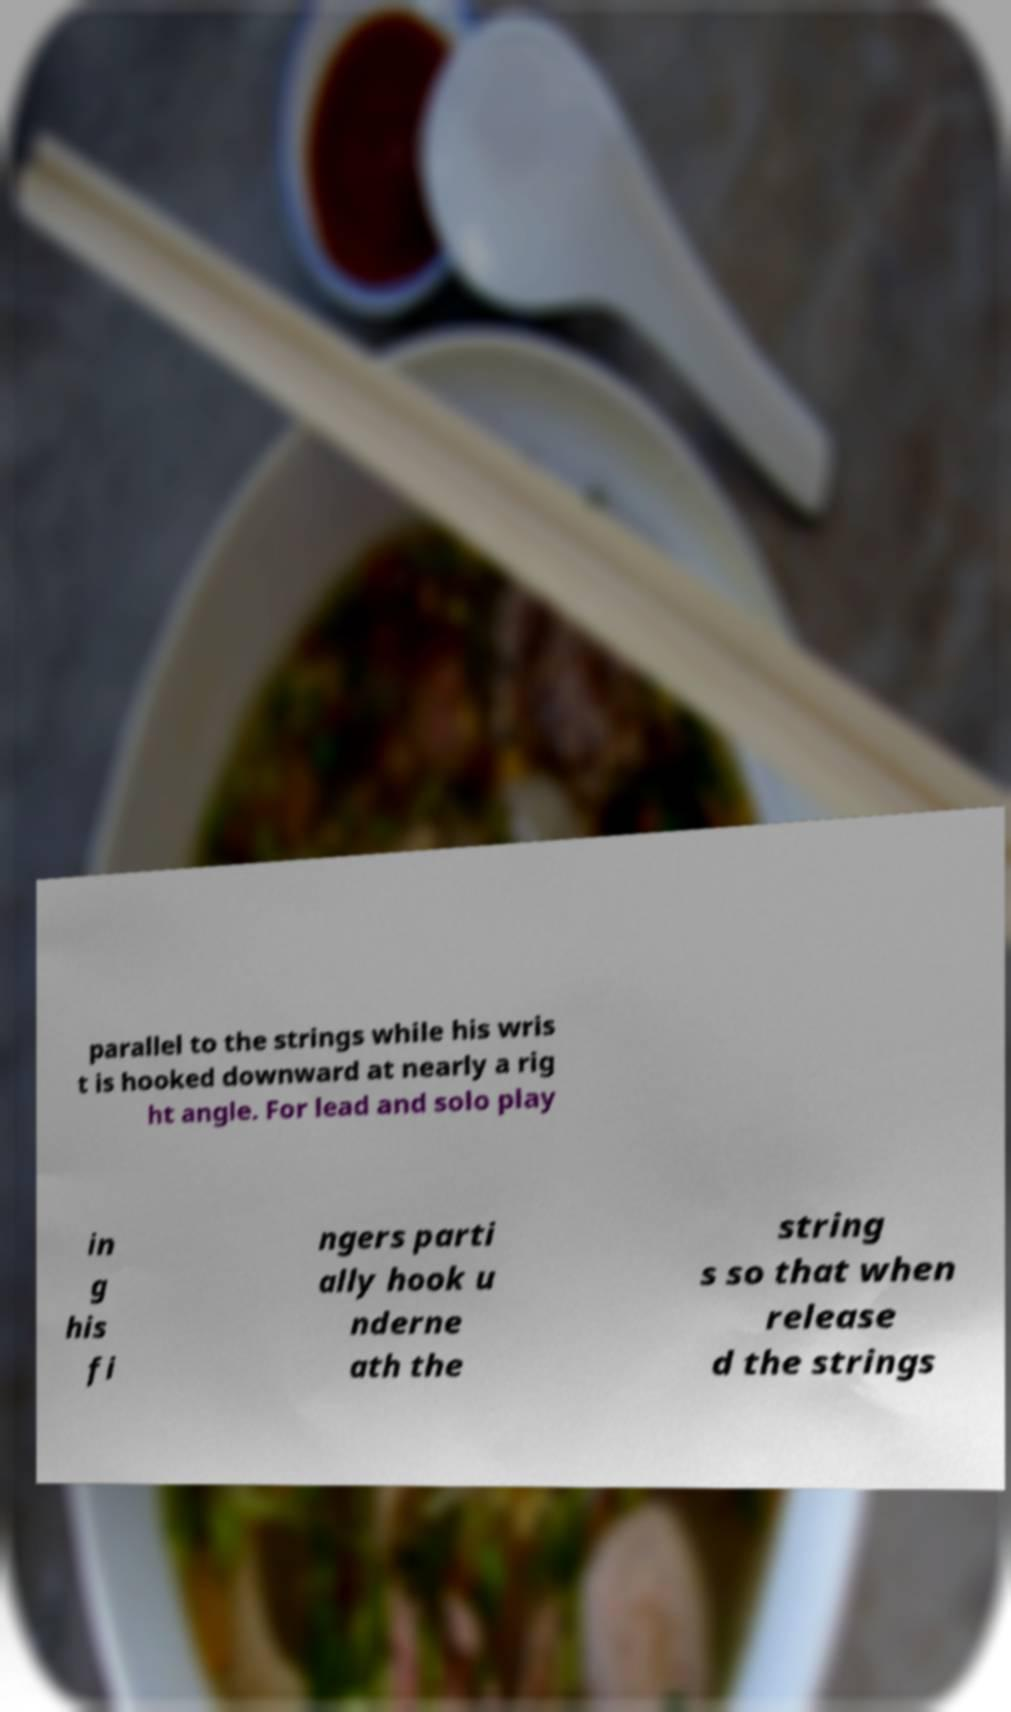Can you read and provide the text displayed in the image?This photo seems to have some interesting text. Can you extract and type it out for me? parallel to the strings while his wris t is hooked downward at nearly a rig ht angle. For lead and solo play in g his fi ngers parti ally hook u nderne ath the string s so that when release d the strings 